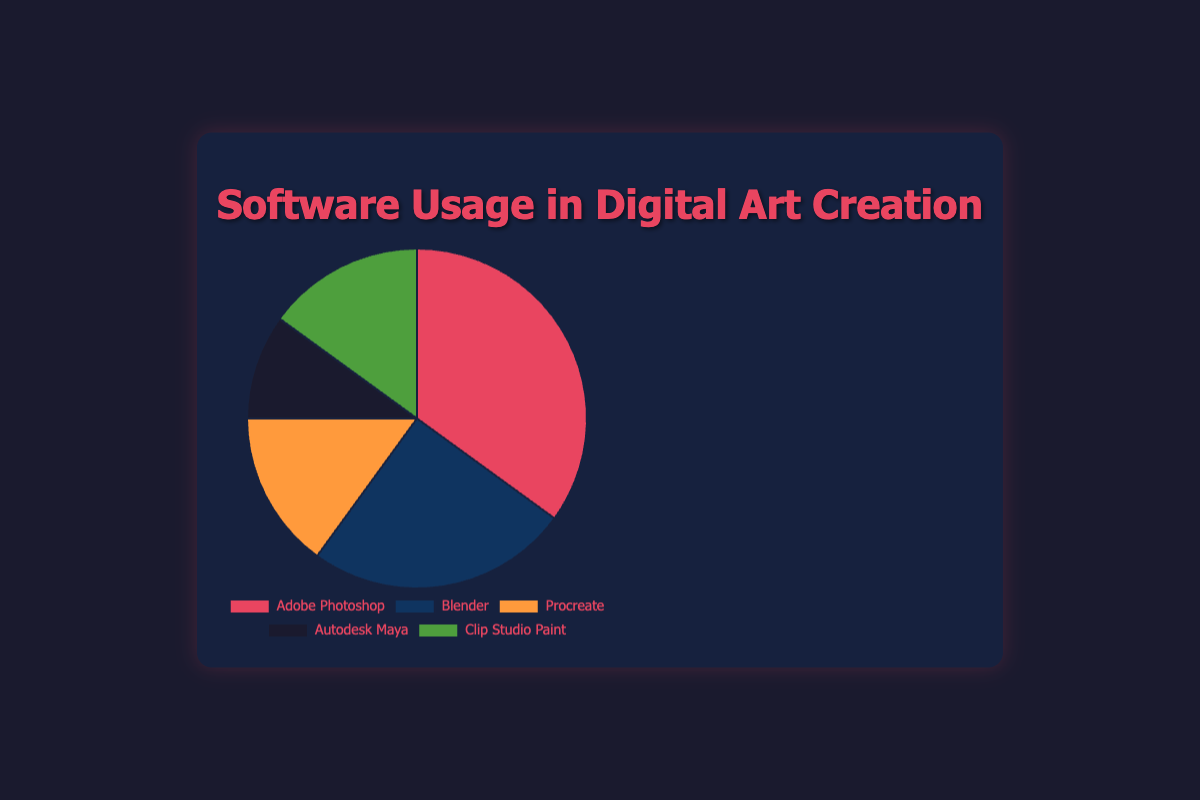What percentage of digital artists use Adobe Photoshop? The figure shows a pie chart with percentages associated with each software. Adobe Photoshop is noted to have a 35% usage.
Answer: 35% Which software is least used by digital artists according to the chart? The pie chart displays the usage percentages of different software. Autodesk Maya has the smallest segment with a 10% usage.
Answer: Autodesk Maya What is the combined usage percentage for Procreate and Clip Studio Paint? According to the chart, Procreate and Clip Studio Paint both have a usage percentage of 15%. Adding these together gives 15% + 15% = 30%.
Answer: 30% How much more usage percentage does Adobe Photoshop have compared to Blender? The chart shows Adobe Photoshop has 35% usage while Blender has 25%. Subtracting these gives 35% - 25% = 10%.
Answer: 10% Which software has a usage percentage closest to Autodesk Maya? Autodesk Maya has a 10% usage. The closest percentage to this is by Blender, which has 25%, Procreate, and Clip Studio Paint each with 15%. Among these, Procreate and Clip Studio Paint both with 15% are closest to 10%.
Answer: Procreate and Clip Studio Paint Which segment of the chart is represented by the color red? Visually inspecting the chart, the segment colored red represents Adobe Photoshop.
Answer: Adobe Photoshop Is the usage percentage of Blender greater than that of Procreate? The pie chart indicates Blender has 25% usage while Procreate has 15%. Therefore, Blender’s usage percentage is greater.
Answer: Yes How much more percentage do Adobe Photoshop and Blender combined have compared to Autodesk Maya? Adobe Photoshop and Blender combined have 35% + 25% = 60%. Autodesk Maya alone has 10%. The difference is 60% - 10% = 50%.
Answer: 50% Which two software have equal usage percentages according to the chart? The chart clearly shows that Procreate and Clip Studio Paint both have a 15% usage percentage.
Answer: Procreate and Clip Studio Paint What is the average usage percentage of all the software tools displayed in the chart? The percentages are 35% (Adobe Photoshop), 25% (Blender), 15% (Procreate), 10% (Autodesk Maya), and 15% (Clip Studio Paint). Summing these gives 35 + 25 + 15 + 10 + 15 = 100. There are 5 software tools, so the average is 100/5 = 20%.
Answer: 20% 